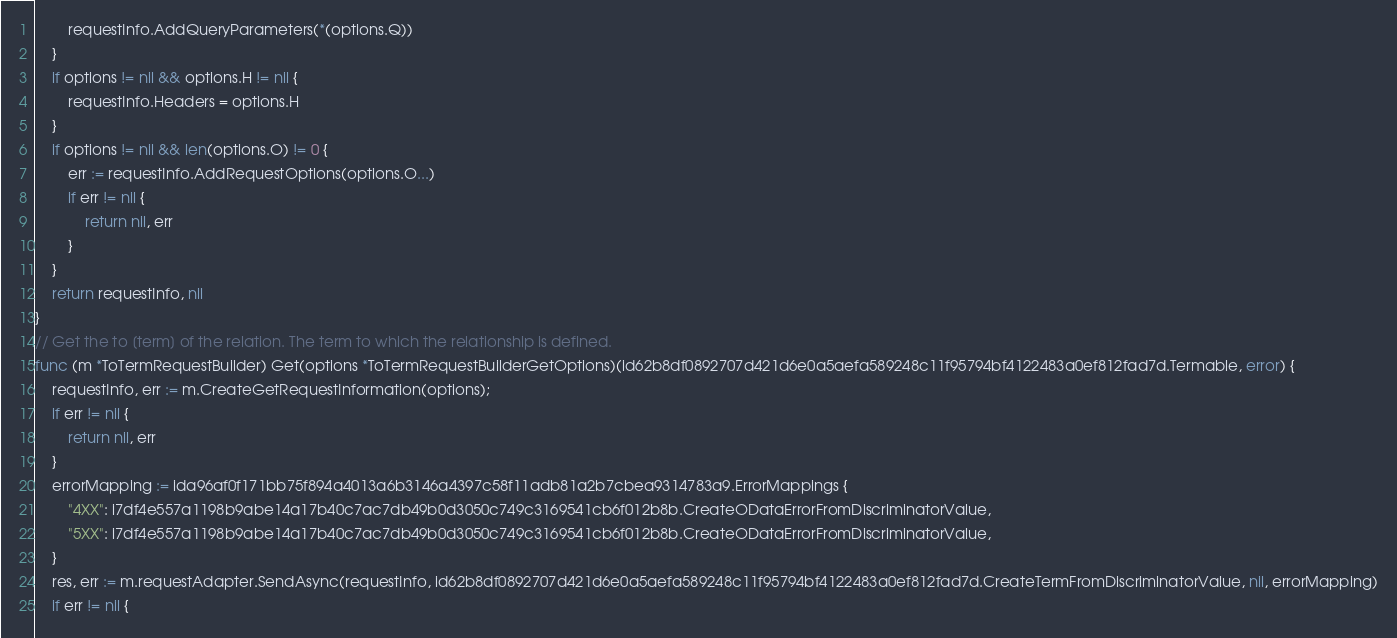<code> <loc_0><loc_0><loc_500><loc_500><_Go_>        requestInfo.AddQueryParameters(*(options.Q))
    }
    if options != nil && options.H != nil {
        requestInfo.Headers = options.H
    }
    if options != nil && len(options.O) != 0 {
        err := requestInfo.AddRequestOptions(options.O...)
        if err != nil {
            return nil, err
        }
    }
    return requestInfo, nil
}
// Get the to [term] of the relation. The term to which the relationship is defined.
func (m *ToTermRequestBuilder) Get(options *ToTermRequestBuilderGetOptions)(id62b8df0892707d421d6e0a5aefa589248c11f95794bf4122483a0ef812fad7d.Termable, error) {
    requestInfo, err := m.CreateGetRequestInformation(options);
    if err != nil {
        return nil, err
    }
    errorMapping := ida96af0f171bb75f894a4013a6b3146a4397c58f11adb81a2b7cbea9314783a9.ErrorMappings {
        "4XX": i7df4e557a1198b9abe14a17b40c7ac7db49b0d3050c749c3169541cb6f012b8b.CreateODataErrorFromDiscriminatorValue,
        "5XX": i7df4e557a1198b9abe14a17b40c7ac7db49b0d3050c749c3169541cb6f012b8b.CreateODataErrorFromDiscriminatorValue,
    }
    res, err := m.requestAdapter.SendAsync(requestInfo, id62b8df0892707d421d6e0a5aefa589248c11f95794bf4122483a0ef812fad7d.CreateTermFromDiscriminatorValue, nil, errorMapping)
    if err != nil {</code> 